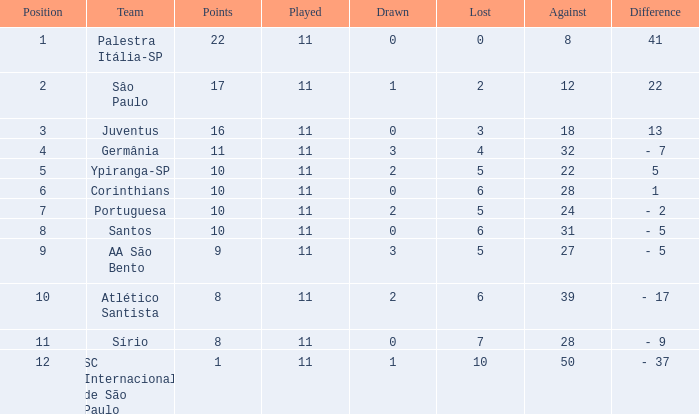What is the overall sum of points when the difference in value is 13 and the lost value exceeds 3? None. 